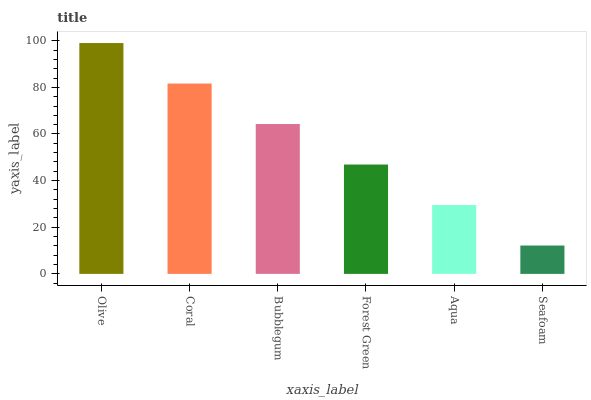Is Seafoam the minimum?
Answer yes or no. Yes. Is Olive the maximum?
Answer yes or no. Yes. Is Coral the minimum?
Answer yes or no. No. Is Coral the maximum?
Answer yes or no. No. Is Olive greater than Coral?
Answer yes or no. Yes. Is Coral less than Olive?
Answer yes or no. Yes. Is Coral greater than Olive?
Answer yes or no. No. Is Olive less than Coral?
Answer yes or no. No. Is Bubblegum the high median?
Answer yes or no. Yes. Is Forest Green the low median?
Answer yes or no. Yes. Is Aqua the high median?
Answer yes or no. No. Is Aqua the low median?
Answer yes or no. No. 